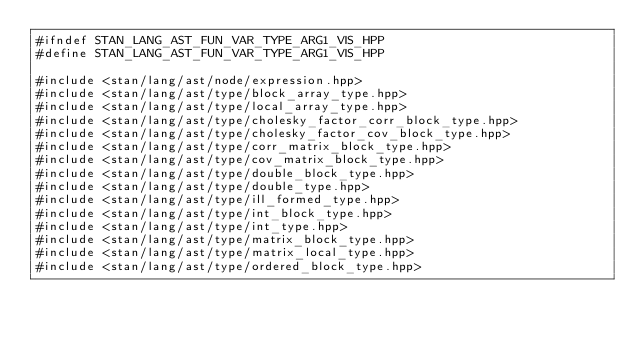<code> <loc_0><loc_0><loc_500><loc_500><_C++_>#ifndef STAN_LANG_AST_FUN_VAR_TYPE_ARG1_VIS_HPP
#define STAN_LANG_AST_FUN_VAR_TYPE_ARG1_VIS_HPP

#include <stan/lang/ast/node/expression.hpp>
#include <stan/lang/ast/type/block_array_type.hpp>
#include <stan/lang/ast/type/local_array_type.hpp>
#include <stan/lang/ast/type/cholesky_factor_corr_block_type.hpp>
#include <stan/lang/ast/type/cholesky_factor_cov_block_type.hpp>
#include <stan/lang/ast/type/corr_matrix_block_type.hpp>
#include <stan/lang/ast/type/cov_matrix_block_type.hpp>
#include <stan/lang/ast/type/double_block_type.hpp>
#include <stan/lang/ast/type/double_type.hpp>
#include <stan/lang/ast/type/ill_formed_type.hpp>
#include <stan/lang/ast/type/int_block_type.hpp>
#include <stan/lang/ast/type/int_type.hpp>
#include <stan/lang/ast/type/matrix_block_type.hpp>
#include <stan/lang/ast/type/matrix_local_type.hpp>
#include <stan/lang/ast/type/ordered_block_type.hpp></code> 